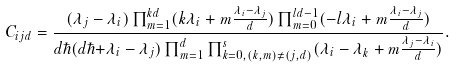Convert formula to latex. <formula><loc_0><loc_0><loc_500><loc_500>C _ { i j d } = \frac { ( \lambda _ { j } - \lambda _ { i } ) \prod _ { m = 1 } ^ { k d } ( k \lambda _ { i } + m \frac { \lambda _ { i } - \lambda _ { j } } { d } ) \prod _ { m = 0 } ^ { l d - 1 } ( - l \lambda _ { i } + m \frac { \lambda _ { i } - \lambda _ { j } } { d } ) } { d \hbar { ( } d \hbar { + } \lambda _ { i } - \lambda _ { j } ) \prod _ { m = 1 } ^ { d } \prod _ { k = 0 , ( k , m ) \neq ( j , d ) } ^ { s } ( \lambda _ { i } - \lambda _ { k } + m \frac { \lambda _ { j } - \lambda _ { i } } { d } ) } .</formula> 